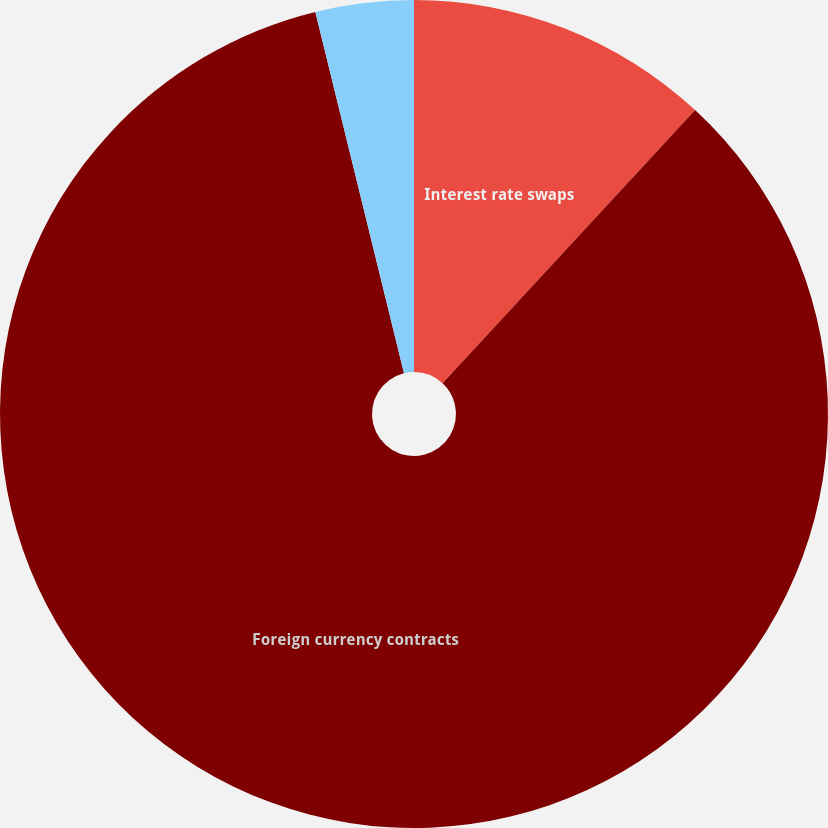Convert chart to OTSL. <chart><loc_0><loc_0><loc_500><loc_500><pie_chart><fcel>Interest rate swaps<fcel>Foreign currency contracts<fcel>Income tax benefit/(expense)<nl><fcel>11.88%<fcel>84.29%<fcel>3.83%<nl></chart> 